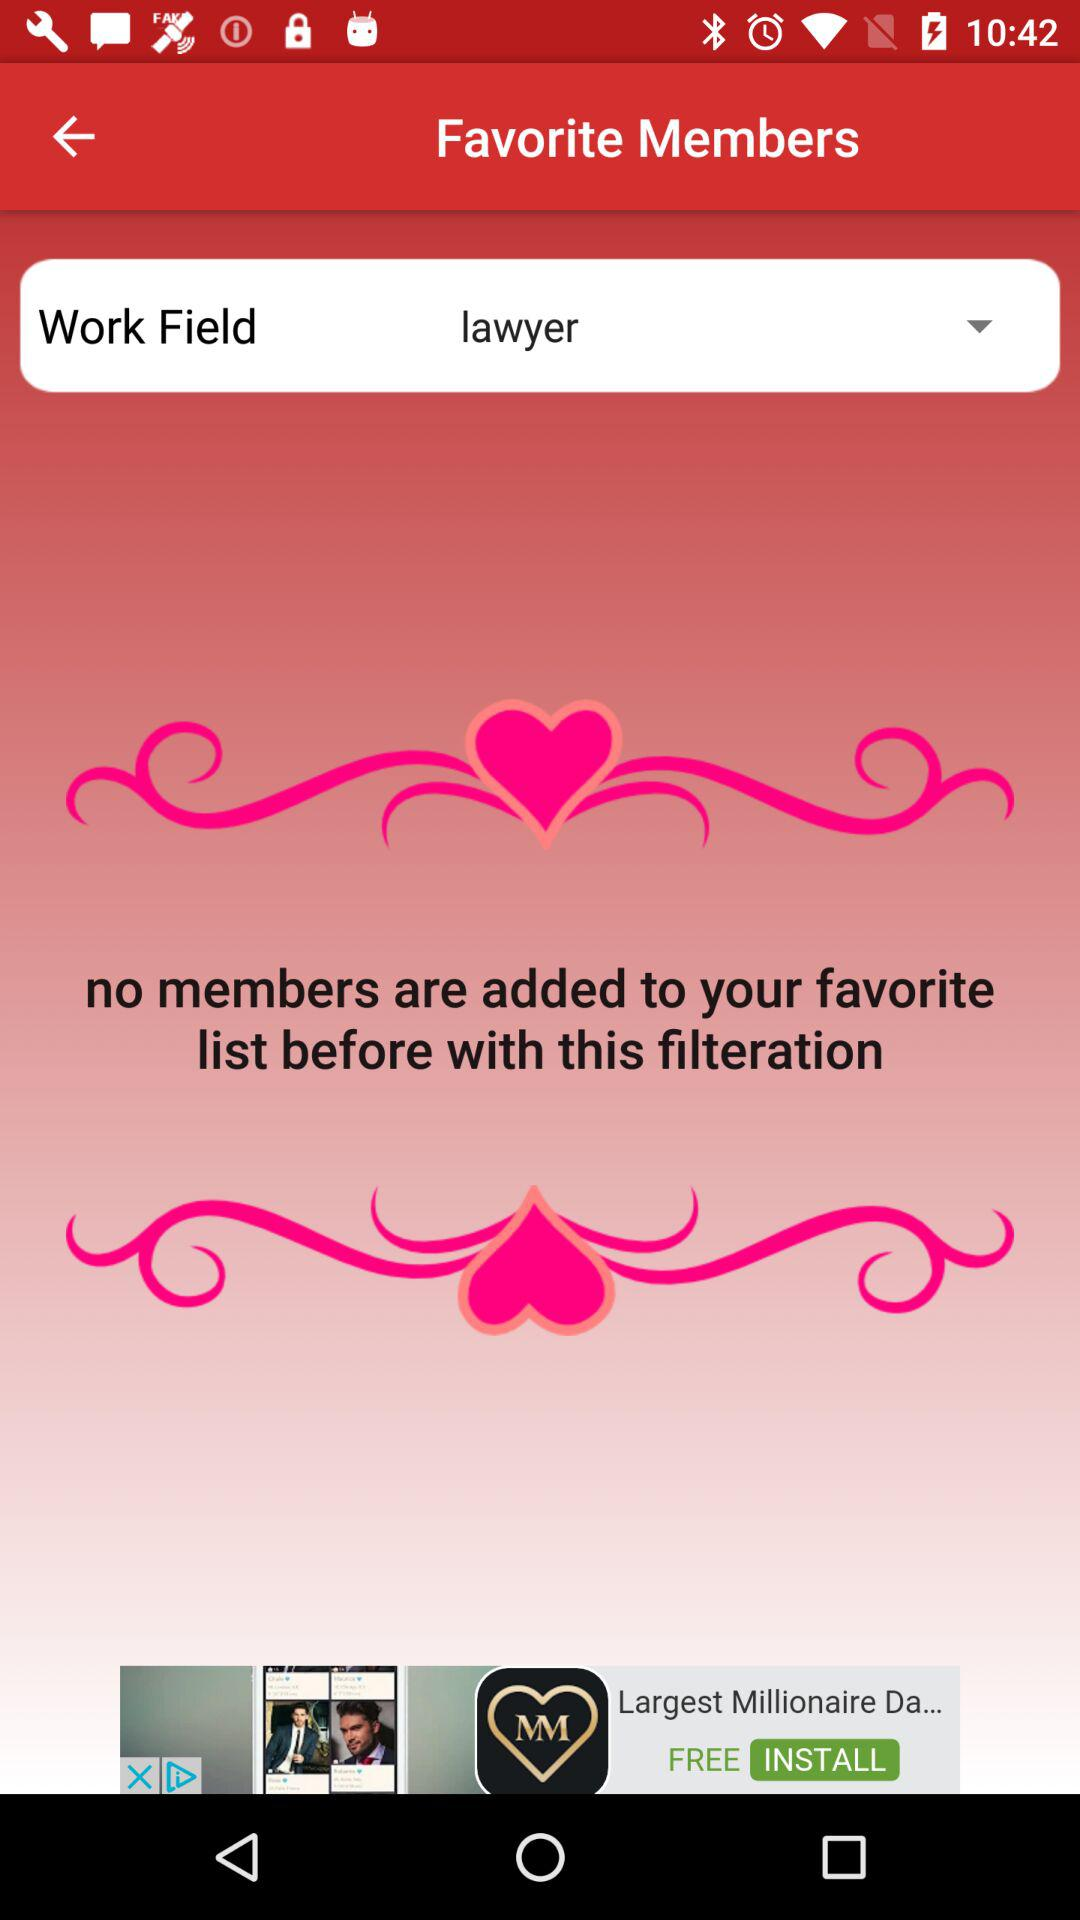How many pink hearts are displayed in total?
Answer the question using a single word or phrase. 2 